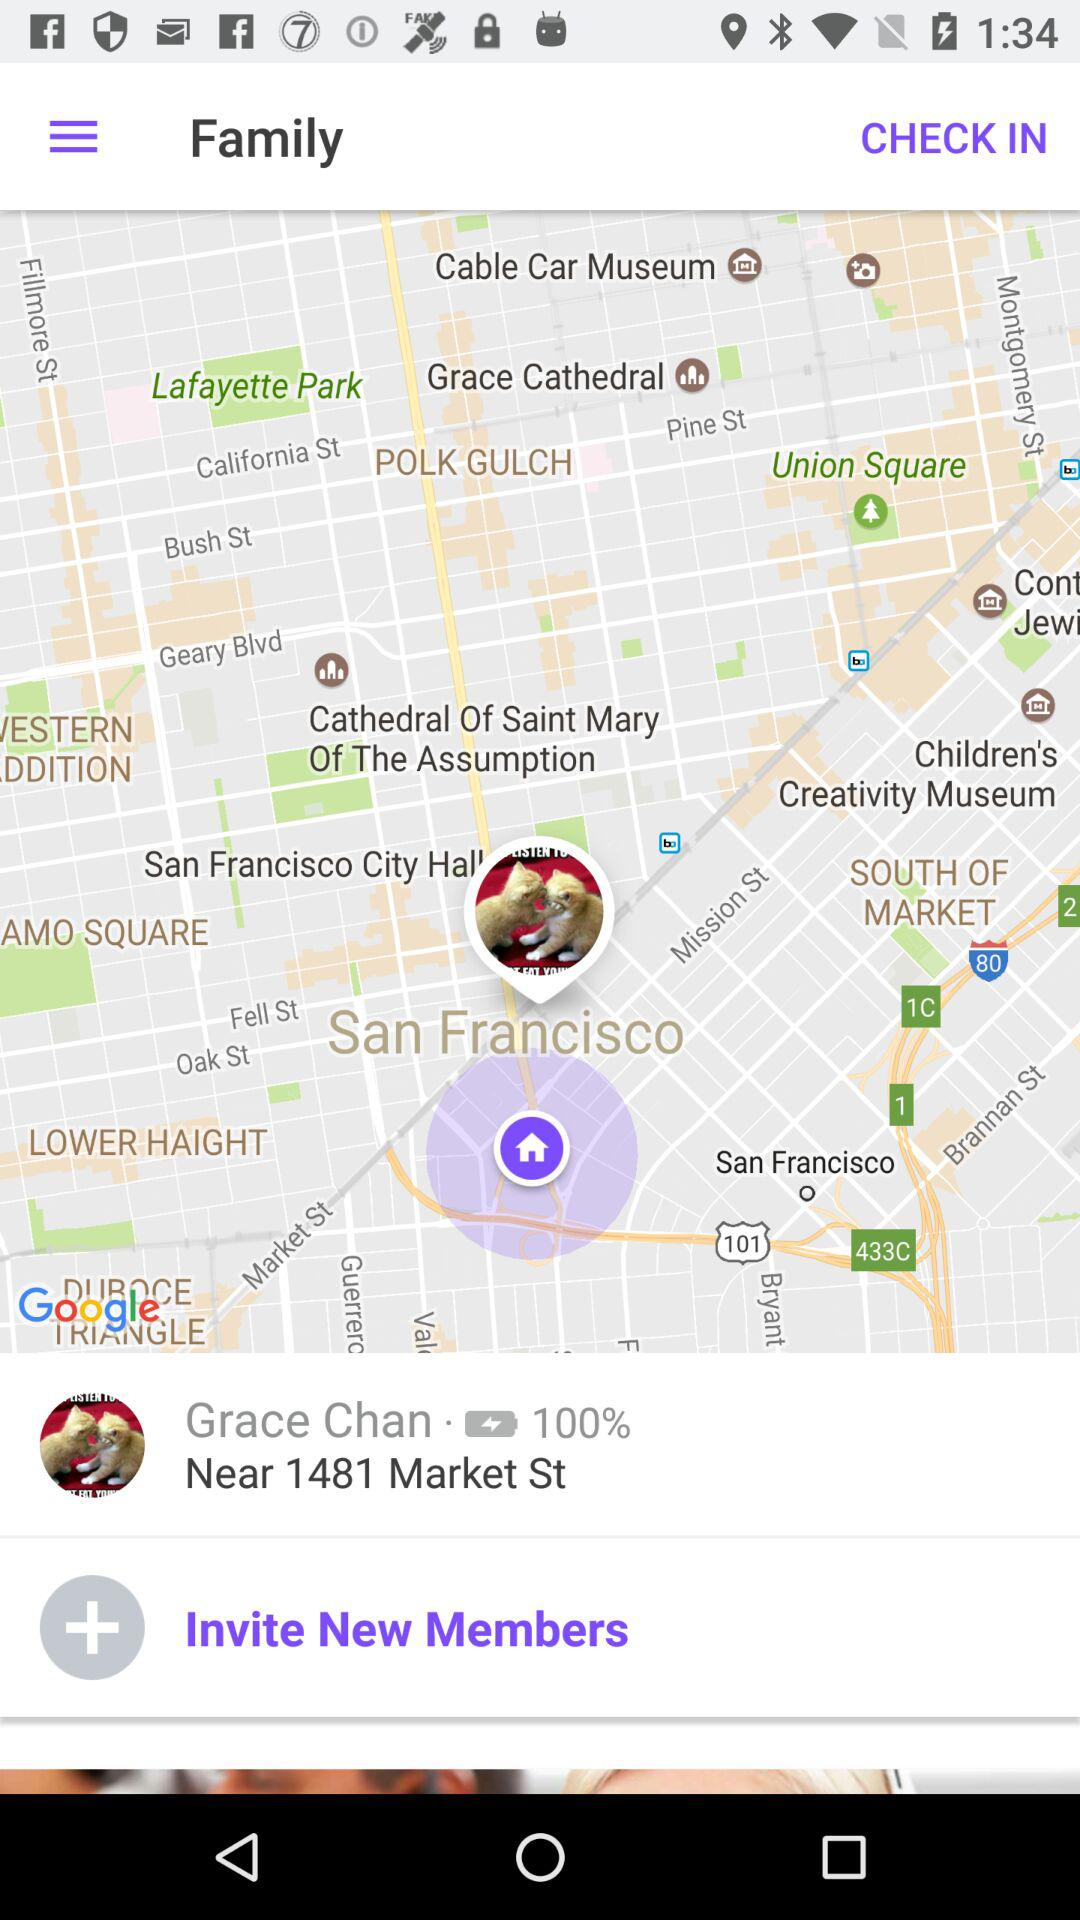What is the person's name? The person's name is Grace Chan. 